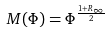Convert formula to latex. <formula><loc_0><loc_0><loc_500><loc_500>M ( \Phi ) = \Phi ^ { \frac { 1 + R _ { \infty } } { 2 } }</formula> 